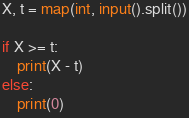<code> <loc_0><loc_0><loc_500><loc_500><_Python_>X, t = map(int, input().split())

if X >= t:
    print(X - t)
else:
    print(0)</code> 